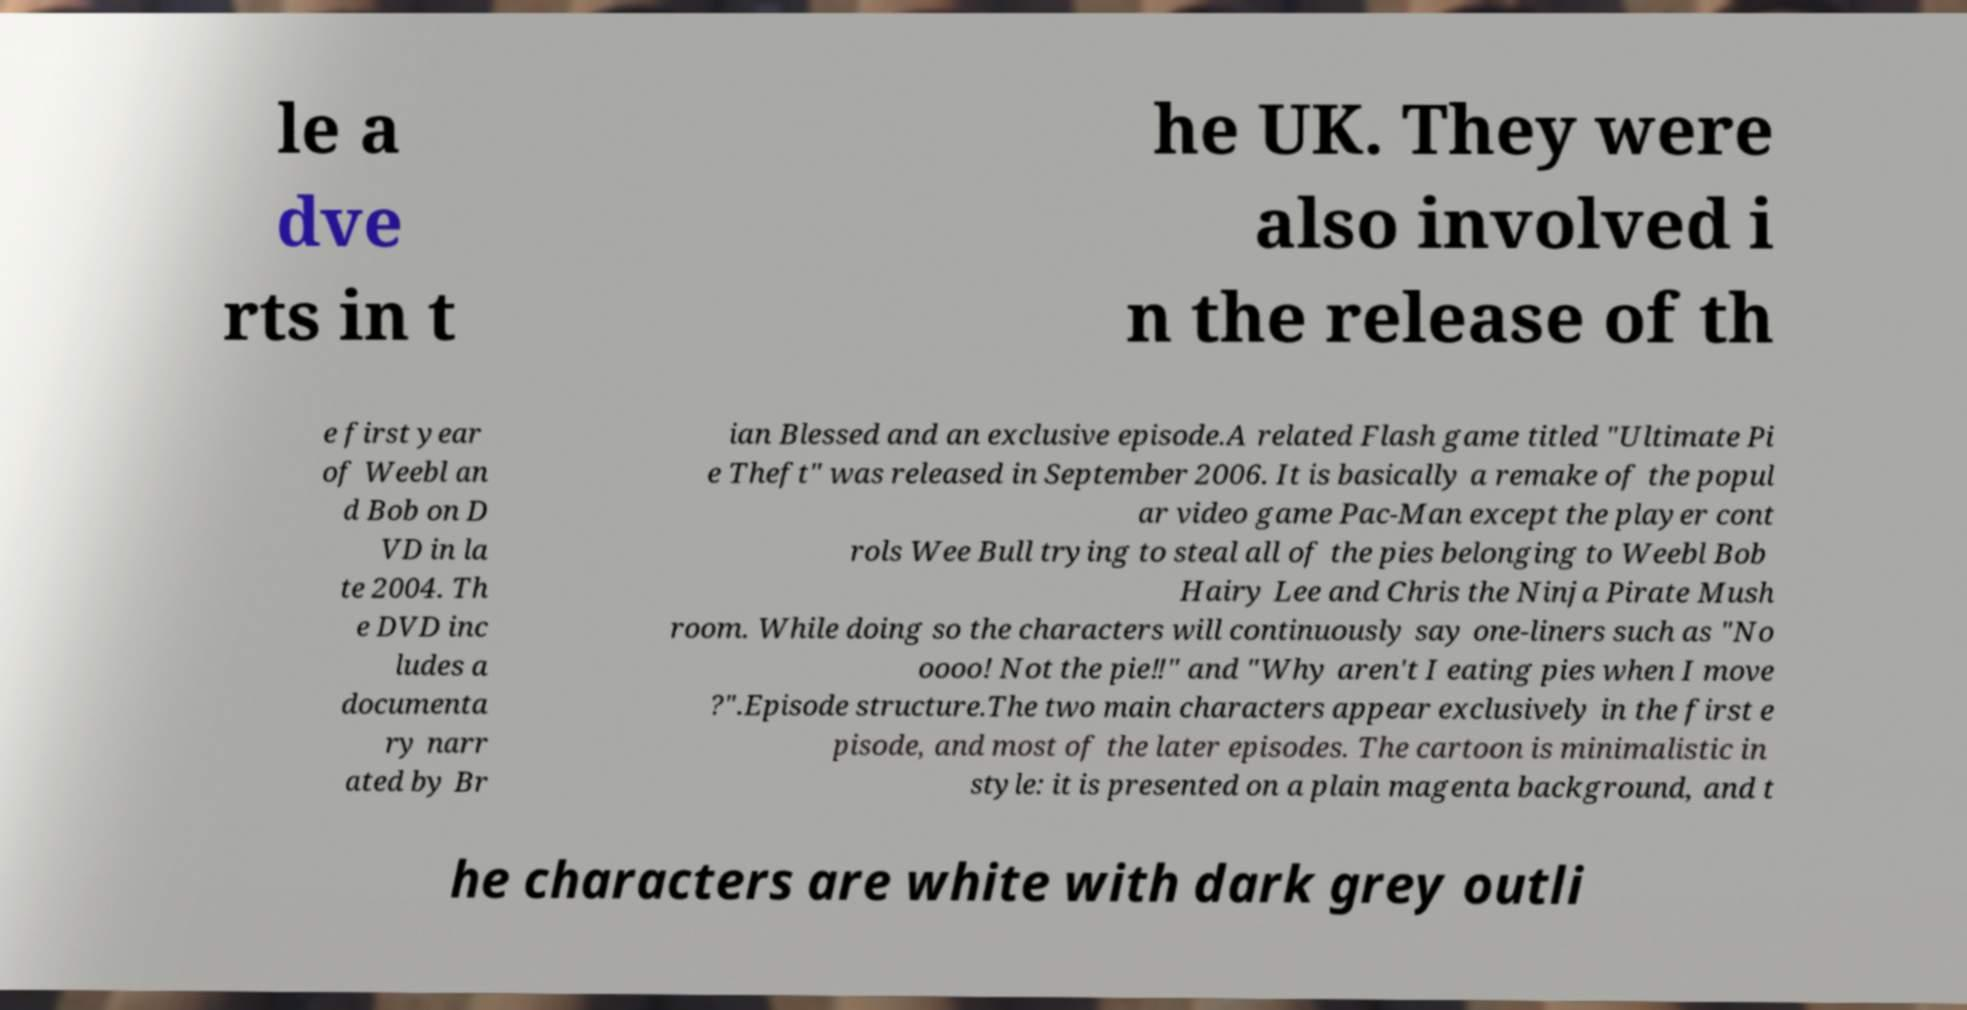Can you read and provide the text displayed in the image?This photo seems to have some interesting text. Can you extract and type it out for me? le a dve rts in t he UK. They were also involved i n the release of th e first year of Weebl an d Bob on D VD in la te 2004. Th e DVD inc ludes a documenta ry narr ated by Br ian Blessed and an exclusive episode.A related Flash game titled "Ultimate Pi e Theft" was released in September 2006. It is basically a remake of the popul ar video game Pac-Man except the player cont rols Wee Bull trying to steal all of the pies belonging to Weebl Bob Hairy Lee and Chris the Ninja Pirate Mush room. While doing so the characters will continuously say one-liners such as "No oooo! Not the pie‼" and "Why aren't I eating pies when I move ?".Episode structure.The two main characters appear exclusively in the first e pisode, and most of the later episodes. The cartoon is minimalistic in style: it is presented on a plain magenta background, and t he characters are white with dark grey outli 